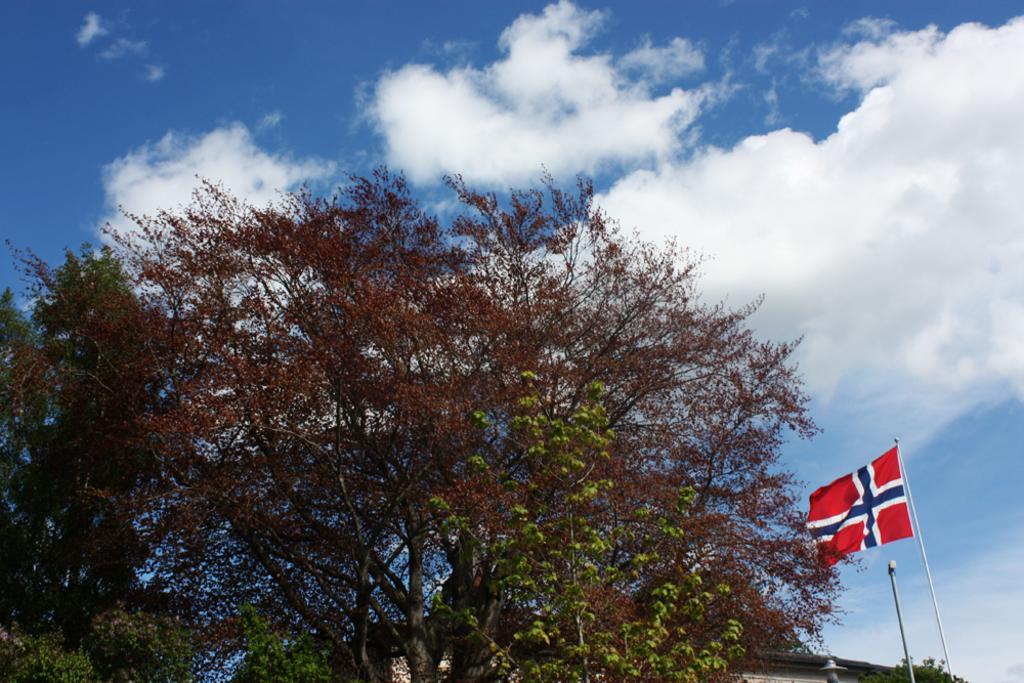Describe this image in one or two sentences. In this image I can see a tree which is green and brown in color and a flag. I can see a building, a pole and the sky in the background. 